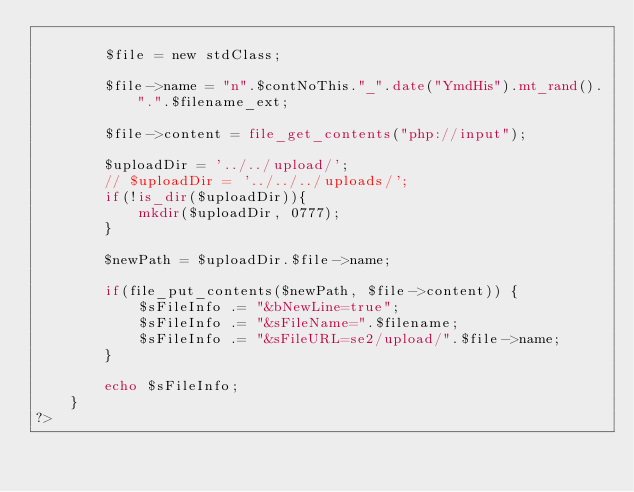Convert code to text. <code><loc_0><loc_0><loc_500><loc_500><_PHP_>
		$file = new stdClass;

		$file->name = "n".$contNoThis."_".date("YmdHis").mt_rand().".".$filename_ext;

		$file->content = file_get_contents("php://input");

		$uploadDir = '../../upload/';
		// $uploadDir = '../../../uploads/';
		if(!is_dir($uploadDir)){
			mkdir($uploadDir, 0777);
		}
		
		$newPath = $uploadDir.$file->name;
		
		if(file_put_contents($newPath, $file->content)) {
			$sFileInfo .= "&bNewLine=true";
			$sFileInfo .= "&sFileName=".$filename;
			$sFileInfo .= "&sFileURL=se2/upload/".$file->name;
		}
		
		echo $sFileInfo;
	}
?></code> 